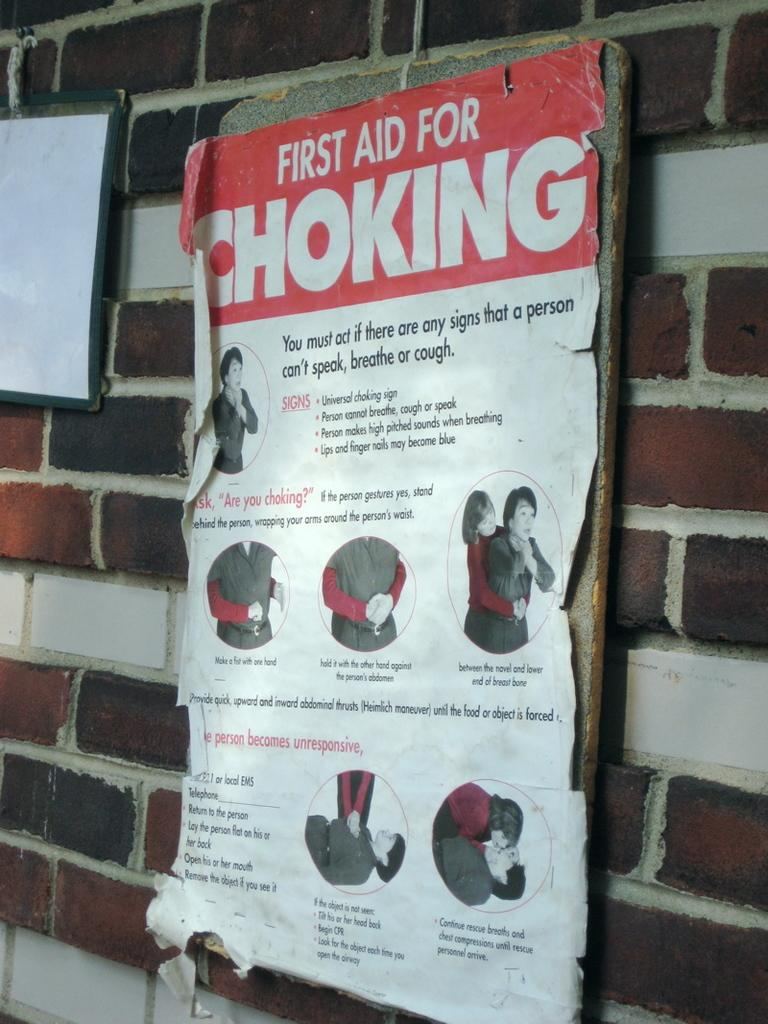What is located on the right side of the image? There is a wall on the right side of the image. What is attached to the wall? There are two boards on the wall. What can be seen on the boards? There is text and depictions of persons on the boards. Can you tell me how the seashore is depicted on the boards? There is no depiction of a seashore on the boards; they feature text and depictions of persons. How many bites are visible on the persons depicted on the boards? There are no bites depicted on the persons shown on the boards. 